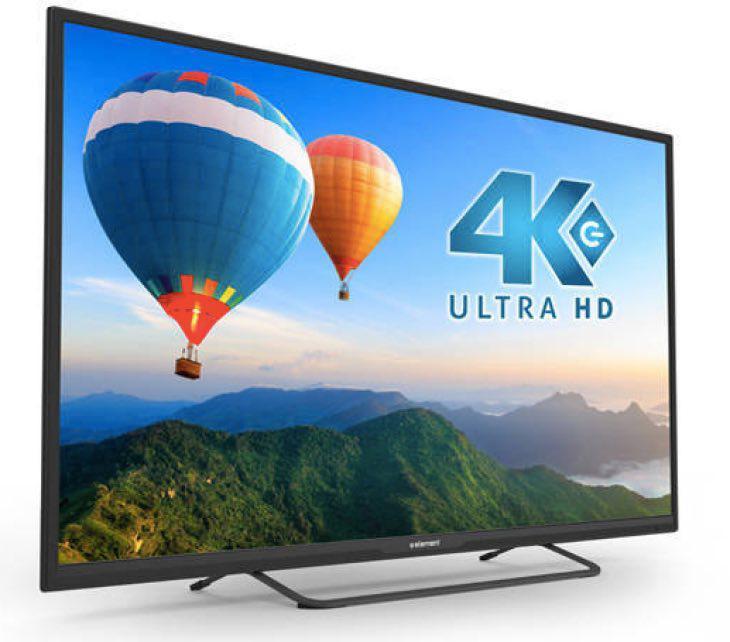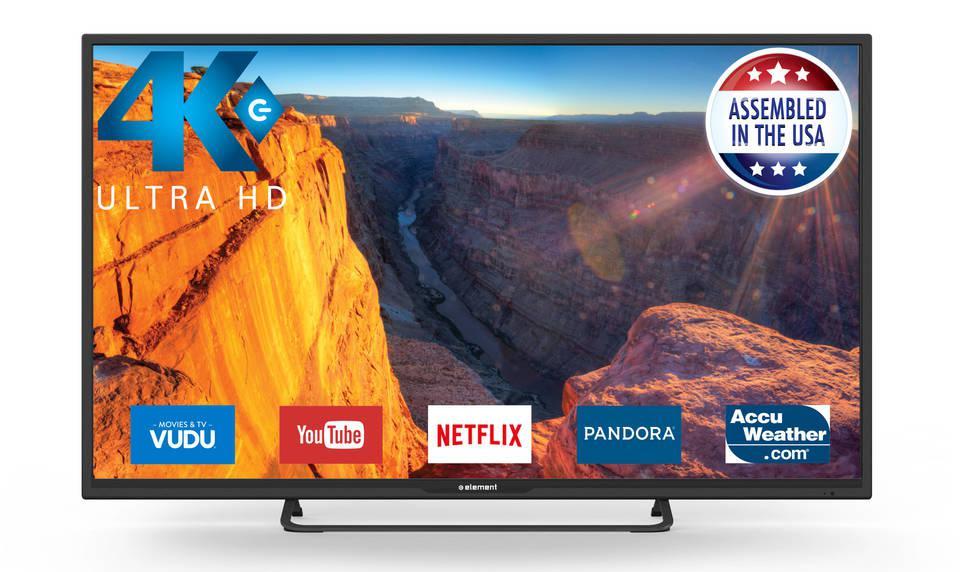The first image is the image on the left, the second image is the image on the right. Considering the images on both sides, is "Exactly one television has end stands." valid? Answer yes or no. No. 